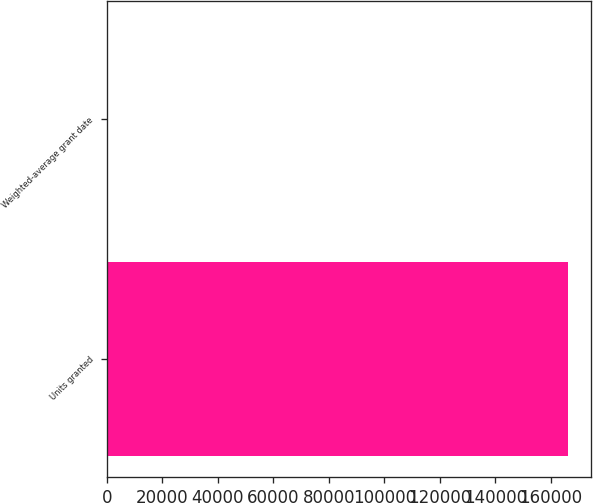<chart> <loc_0><loc_0><loc_500><loc_500><bar_chart><fcel>Units granted<fcel>Weighted-average grant date<nl><fcel>166244<fcel>54.86<nl></chart> 